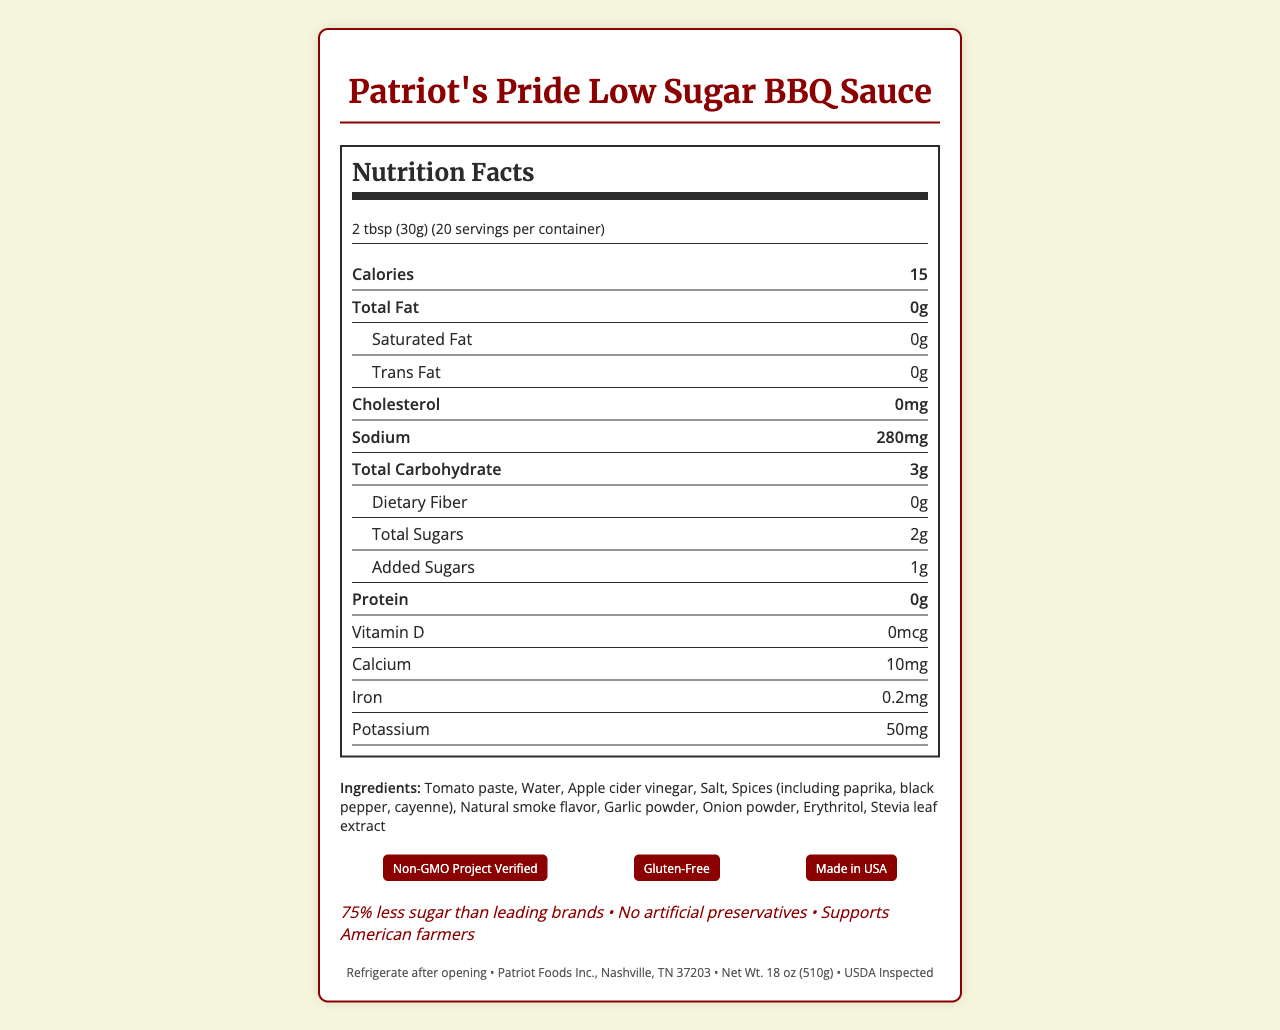what is the serving size for Patriot's Pride Low Sugar BBQ Sauce? The serving size is listed as "2 tbsp (30g)" in the document.
Answer: 2 tbsp (30g) How many calories are there per serving? The document states that each serving contains 15 calories.
Answer: 15 Which ingredient in Patriot's Pride Low Sugar BBQ Sauce is a sweetener? The ingredients list includes Erythritol and Stevia leaf extract, which are used as sweeteners.
Answer: Erythritol and Stevia leaf extract what is the total carbohydrate content per serving? The content for total carbohydrates per serving is listed as 3g.
Answer: 3g How much sodium does each serving contain? The document specifies that each serving contains 280mg of sodium.
Answer: 280mg how many grams of protein per serving does Patriot's Pride Low Sugar BBQ Sauce have? The "Protein" section in the nutrition facts indicates 0g per serving.
Answer: 0g What certifications does this BBQ sauce have? A. Non-GMO Project Verified B. USDA Organic C. Made in USA D. Gluten-Free E. Contains no major allergens The document lists "Non-GMO Project Verified," "Made in USA," and "Gluten-Free," but not "USDA Organic."
Answer: A, C, D How much added sugar is present in each serving? A. 0g B. 1g C. 2g D. 3g E. 4g The added sugars per serving listed are 1g.
Answer: B Is Patriot's Pride Low Sugar BBQ Sauce allergen-free? (Yes/No) The allergen statement specifies that the product contains no major allergens.
Answer: Yes Summarize the key features of Patriot's Pride Low Sugar BBQ Sauce. This summary encapsulates the main characteristics and nutritional benefits of the BBQ sauce, as well as its certifications and storage instructions.
Answer: Patriot's Pride Low Sugar BBQ Sauce is a low-calorie, low-sugar condiment with only 15 calories and 2g of total sugars per serving. It is free from major allergens, has no artificial preservatives, and is certified Non-GMO, gluten-free, and made in the USA. The main ingredients include tomato paste, apple cider vinegar, and natural smoke flavor, among others. It also prominently supports American farmers and should be refrigerated after opening. Is Patriot's Pride Low Sugar BBQ Sauce suitable for a keto diet? The document lists the nutritional content but does not provide enough information to conclusively determine if the product fits a keto diet.
Answer: Not enough information 